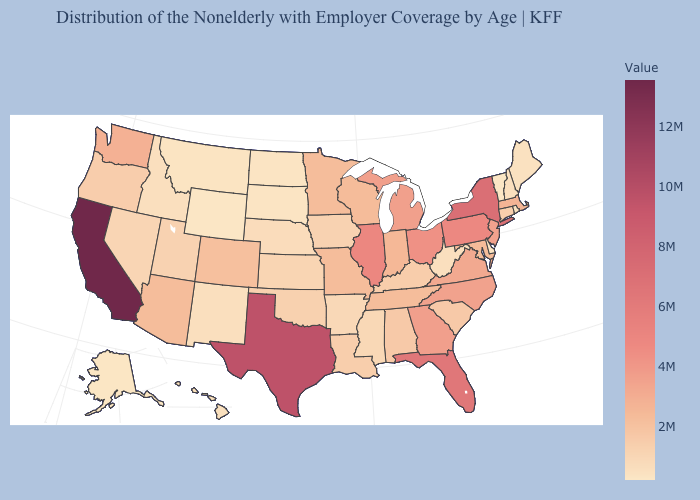Is the legend a continuous bar?
Short answer required. Yes. Does Indiana have the highest value in the USA?
Be succinct. No. Which states have the lowest value in the West?
Keep it brief. Wyoming. Which states have the lowest value in the West?
Give a very brief answer. Wyoming. 